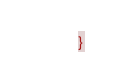<code> <loc_0><loc_0><loc_500><loc_500><_CSS_>}</code> 